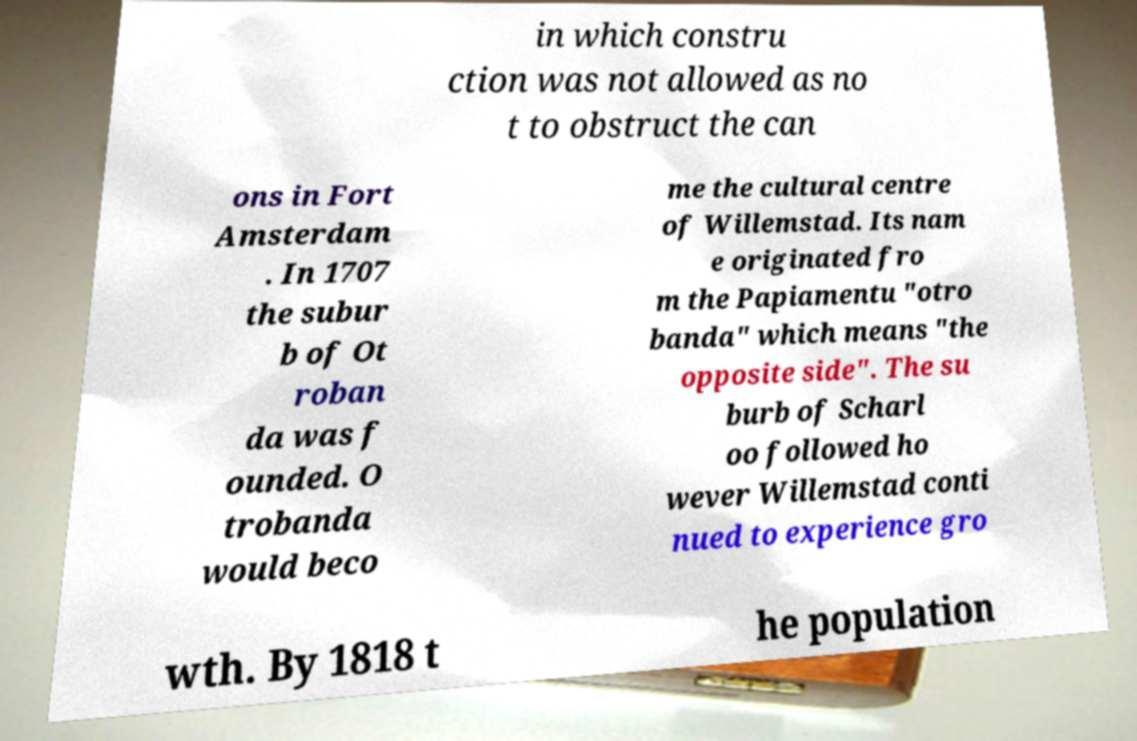Could you extract and type out the text from this image? in which constru ction was not allowed as no t to obstruct the can ons in Fort Amsterdam . In 1707 the subur b of Ot roban da was f ounded. O trobanda would beco me the cultural centre of Willemstad. Its nam e originated fro m the Papiamentu "otro banda" which means "the opposite side". The su burb of Scharl oo followed ho wever Willemstad conti nued to experience gro wth. By 1818 t he population 